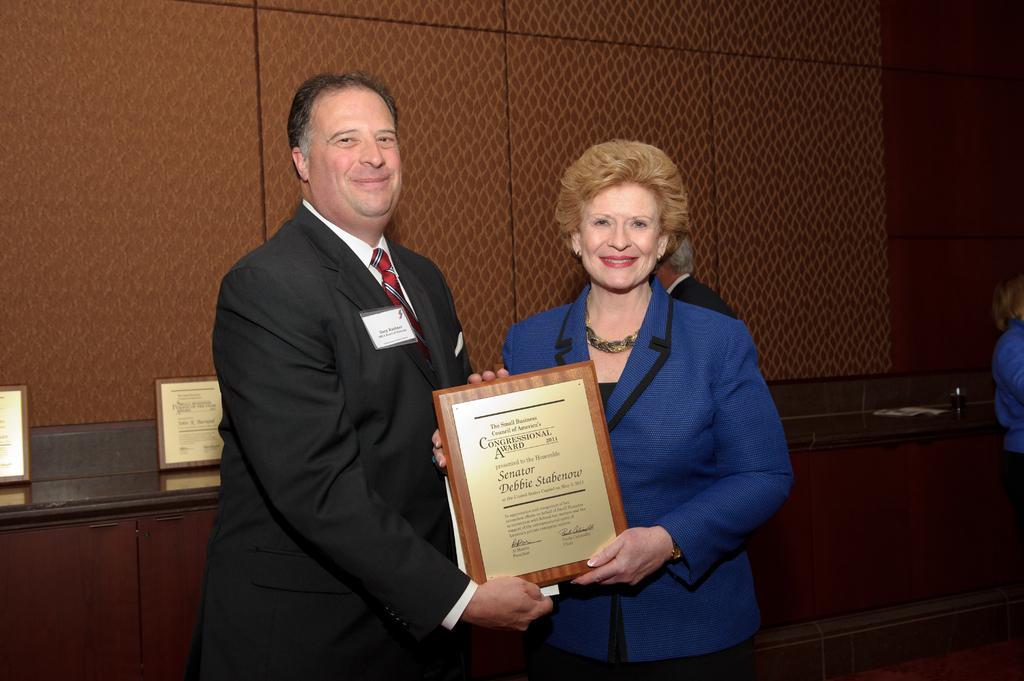Describe this image in one or two sentences. This image consists of two persons. To the left, there is a man wearing black suit and white shirt. Beside him, there is a woman wearing blue jacket and holding a momento. In the background, there is a wall in brown color and there are frames kept on the desk. 